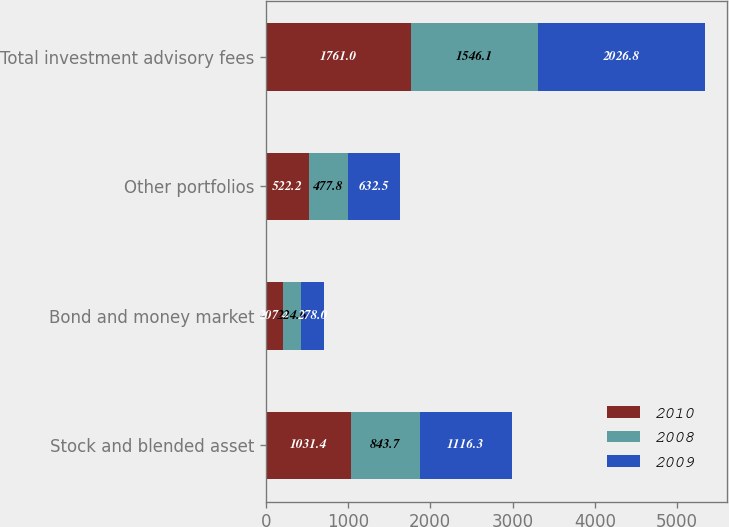<chart> <loc_0><loc_0><loc_500><loc_500><stacked_bar_chart><ecel><fcel>Stock and blended asset<fcel>Bond and money market<fcel>Other portfolios<fcel>Total investment advisory fees<nl><fcel>2010<fcel>1031.4<fcel>207.4<fcel>522.2<fcel>1761<nl><fcel>2008<fcel>843.7<fcel>224.6<fcel>477.8<fcel>1546.1<nl><fcel>2009<fcel>1116.3<fcel>278<fcel>632.5<fcel>2026.8<nl></chart> 